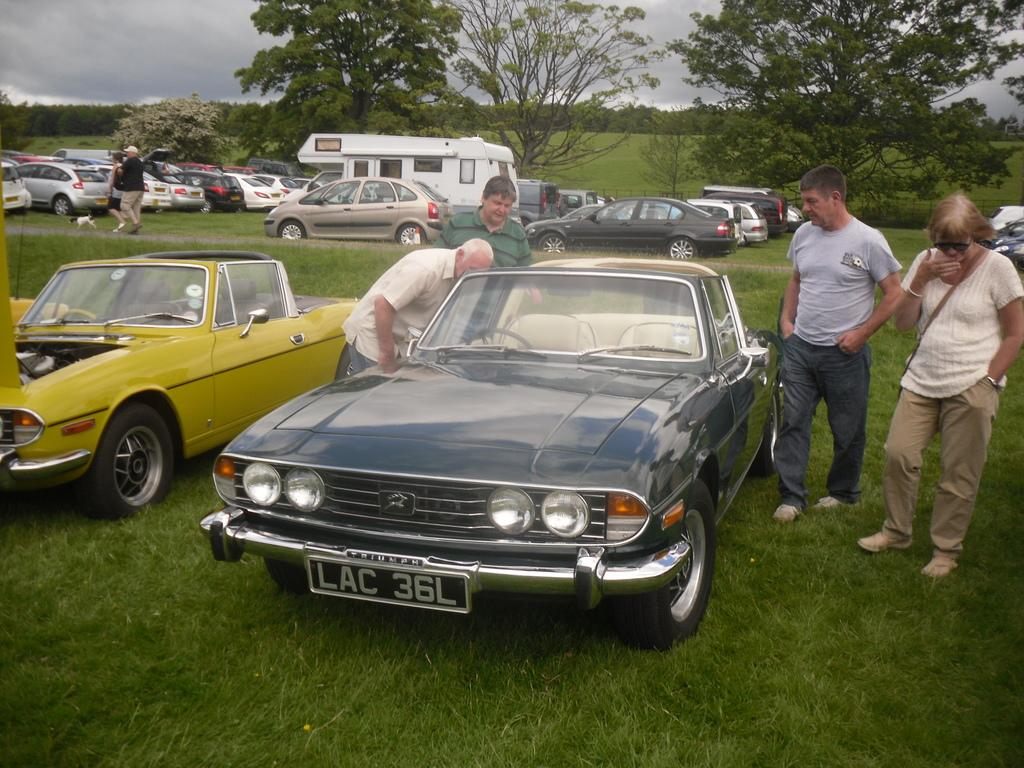What can be seen in the foreground area of the image? In the foreground area of the image, there are vehicles and people on the grassland. Are there any people visible in the background of the image? Yes, there are people in the background of the image. What else can be seen in the background of the image? In the background of the image, there are vehicles, trees, grassland, and the sky. How many pizzas are being eaten by the achiever in the image? There is no achiever or pizzas present in the image. What is the mouth size of the person in the image? The image does not provide information about the mouth size of any person. 